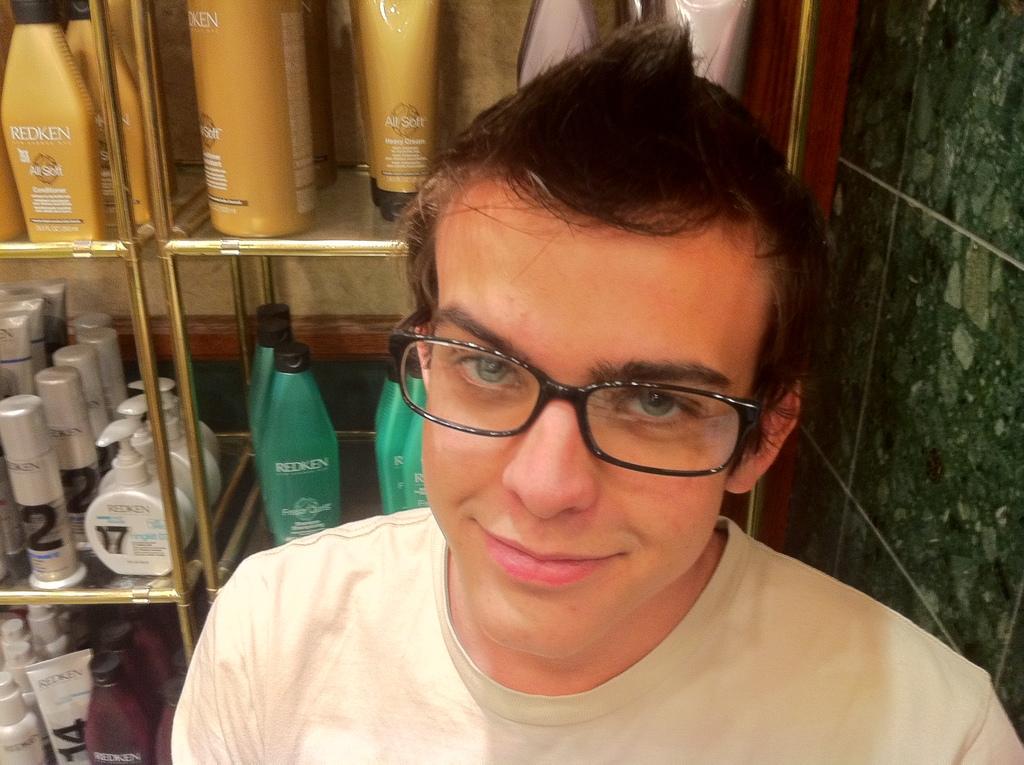What is the brand of the green bottle?
Your answer should be compact. Redken. What brand are the styling products behind him?
Give a very brief answer. Redken. 